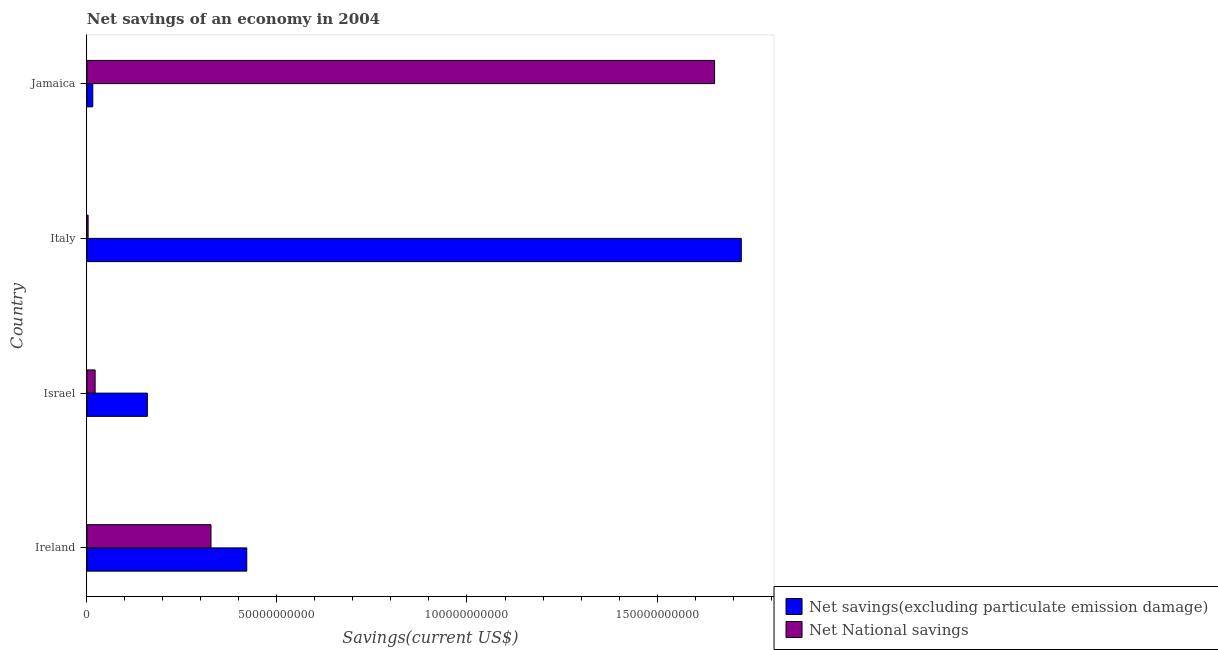How many different coloured bars are there?
Give a very brief answer. 2. Are the number of bars on each tick of the Y-axis equal?
Your answer should be very brief. Yes. What is the label of the 1st group of bars from the top?
Provide a succinct answer. Jamaica. In how many cases, is the number of bars for a given country not equal to the number of legend labels?
Keep it short and to the point. 0. What is the net national savings in Israel?
Make the answer very short. 2.16e+09. Across all countries, what is the maximum net national savings?
Your answer should be very brief. 1.65e+11. Across all countries, what is the minimum net savings(excluding particulate emission damage)?
Offer a very short reply. 1.55e+09. In which country was the net national savings minimum?
Your answer should be very brief. Italy. What is the total net national savings in the graph?
Give a very brief answer. 2.00e+11. What is the difference between the net savings(excluding particulate emission damage) in Ireland and that in Israel?
Ensure brevity in your answer.  2.62e+1. What is the difference between the net savings(excluding particulate emission damage) in Jamaica and the net national savings in Italy?
Provide a succinct answer. 1.23e+09. What is the average net savings(excluding particulate emission damage) per country?
Your response must be concise. 5.79e+1. What is the difference between the net national savings and net savings(excluding particulate emission damage) in Jamaica?
Offer a very short reply. 1.64e+11. What is the ratio of the net national savings in Italy to that in Jamaica?
Your response must be concise. 0. What is the difference between the highest and the second highest net savings(excluding particulate emission damage)?
Your answer should be very brief. 1.30e+11. What is the difference between the highest and the lowest net savings(excluding particulate emission damage)?
Provide a short and direct response. 1.71e+11. In how many countries, is the net national savings greater than the average net national savings taken over all countries?
Your answer should be very brief. 1. What does the 1st bar from the top in Ireland represents?
Give a very brief answer. Net National savings. What does the 2nd bar from the bottom in Jamaica represents?
Your answer should be compact. Net National savings. How many bars are there?
Offer a terse response. 8. Are all the bars in the graph horizontal?
Keep it short and to the point. Yes. How many countries are there in the graph?
Your answer should be very brief. 4. Does the graph contain grids?
Offer a very short reply. No. Where does the legend appear in the graph?
Give a very brief answer. Bottom right. What is the title of the graph?
Keep it short and to the point. Net savings of an economy in 2004. Does "UN agencies" appear as one of the legend labels in the graph?
Offer a very short reply. No. What is the label or title of the X-axis?
Offer a terse response. Savings(current US$). What is the label or title of the Y-axis?
Offer a terse response. Country. What is the Savings(current US$) of Net savings(excluding particulate emission damage) in Ireland?
Offer a terse response. 4.21e+1. What is the Savings(current US$) in Net National savings in Ireland?
Keep it short and to the point. 3.27e+1. What is the Savings(current US$) of Net savings(excluding particulate emission damage) in Israel?
Offer a very short reply. 1.59e+1. What is the Savings(current US$) in Net National savings in Israel?
Offer a terse response. 2.16e+09. What is the Savings(current US$) in Net savings(excluding particulate emission damage) in Italy?
Make the answer very short. 1.72e+11. What is the Savings(current US$) in Net National savings in Italy?
Offer a very short reply. 3.24e+08. What is the Savings(current US$) of Net savings(excluding particulate emission damage) in Jamaica?
Offer a very short reply. 1.55e+09. What is the Savings(current US$) in Net National savings in Jamaica?
Provide a succinct answer. 1.65e+11. Across all countries, what is the maximum Savings(current US$) in Net savings(excluding particulate emission damage)?
Offer a very short reply. 1.72e+11. Across all countries, what is the maximum Savings(current US$) of Net National savings?
Offer a terse response. 1.65e+11. Across all countries, what is the minimum Savings(current US$) of Net savings(excluding particulate emission damage)?
Provide a short and direct response. 1.55e+09. Across all countries, what is the minimum Savings(current US$) of Net National savings?
Keep it short and to the point. 3.24e+08. What is the total Savings(current US$) in Net savings(excluding particulate emission damage) in the graph?
Your response must be concise. 2.32e+11. What is the total Savings(current US$) in Net National savings in the graph?
Offer a very short reply. 2.00e+11. What is the difference between the Savings(current US$) in Net savings(excluding particulate emission damage) in Ireland and that in Israel?
Make the answer very short. 2.62e+1. What is the difference between the Savings(current US$) in Net National savings in Ireland and that in Israel?
Keep it short and to the point. 3.05e+1. What is the difference between the Savings(current US$) of Net savings(excluding particulate emission damage) in Ireland and that in Italy?
Your answer should be very brief. -1.30e+11. What is the difference between the Savings(current US$) in Net National savings in Ireland and that in Italy?
Your response must be concise. 3.23e+1. What is the difference between the Savings(current US$) in Net savings(excluding particulate emission damage) in Ireland and that in Jamaica?
Offer a terse response. 4.05e+1. What is the difference between the Savings(current US$) in Net National savings in Ireland and that in Jamaica?
Keep it short and to the point. -1.32e+11. What is the difference between the Savings(current US$) in Net savings(excluding particulate emission damage) in Israel and that in Italy?
Give a very brief answer. -1.56e+11. What is the difference between the Savings(current US$) of Net National savings in Israel and that in Italy?
Make the answer very short. 1.84e+09. What is the difference between the Savings(current US$) in Net savings(excluding particulate emission damage) in Israel and that in Jamaica?
Provide a short and direct response. 1.44e+1. What is the difference between the Savings(current US$) of Net National savings in Israel and that in Jamaica?
Provide a short and direct response. -1.63e+11. What is the difference between the Savings(current US$) of Net savings(excluding particulate emission damage) in Italy and that in Jamaica?
Your answer should be compact. 1.71e+11. What is the difference between the Savings(current US$) in Net National savings in Italy and that in Jamaica?
Keep it short and to the point. -1.65e+11. What is the difference between the Savings(current US$) in Net savings(excluding particulate emission damage) in Ireland and the Savings(current US$) in Net National savings in Israel?
Provide a succinct answer. 3.99e+1. What is the difference between the Savings(current US$) in Net savings(excluding particulate emission damage) in Ireland and the Savings(current US$) in Net National savings in Italy?
Your answer should be compact. 4.17e+1. What is the difference between the Savings(current US$) in Net savings(excluding particulate emission damage) in Ireland and the Savings(current US$) in Net National savings in Jamaica?
Your answer should be compact. -1.23e+11. What is the difference between the Savings(current US$) in Net savings(excluding particulate emission damage) in Israel and the Savings(current US$) in Net National savings in Italy?
Give a very brief answer. 1.56e+1. What is the difference between the Savings(current US$) in Net savings(excluding particulate emission damage) in Israel and the Savings(current US$) in Net National savings in Jamaica?
Your answer should be compact. -1.49e+11. What is the difference between the Savings(current US$) in Net savings(excluding particulate emission damage) in Italy and the Savings(current US$) in Net National savings in Jamaica?
Give a very brief answer. 7.03e+09. What is the average Savings(current US$) of Net savings(excluding particulate emission damage) per country?
Give a very brief answer. 5.79e+1. What is the average Savings(current US$) in Net National savings per country?
Your response must be concise. 5.01e+1. What is the difference between the Savings(current US$) of Net savings(excluding particulate emission damage) and Savings(current US$) of Net National savings in Ireland?
Keep it short and to the point. 9.41e+09. What is the difference between the Savings(current US$) of Net savings(excluding particulate emission damage) and Savings(current US$) of Net National savings in Israel?
Make the answer very short. 1.37e+1. What is the difference between the Savings(current US$) in Net savings(excluding particulate emission damage) and Savings(current US$) in Net National savings in Italy?
Offer a terse response. 1.72e+11. What is the difference between the Savings(current US$) of Net savings(excluding particulate emission damage) and Savings(current US$) of Net National savings in Jamaica?
Make the answer very short. -1.64e+11. What is the ratio of the Savings(current US$) in Net savings(excluding particulate emission damage) in Ireland to that in Israel?
Give a very brief answer. 2.64. What is the ratio of the Savings(current US$) in Net National savings in Ireland to that in Israel?
Provide a succinct answer. 15.09. What is the ratio of the Savings(current US$) in Net savings(excluding particulate emission damage) in Ireland to that in Italy?
Provide a short and direct response. 0.24. What is the ratio of the Savings(current US$) in Net National savings in Ireland to that in Italy?
Offer a terse response. 100.77. What is the ratio of the Savings(current US$) in Net savings(excluding particulate emission damage) in Ireland to that in Jamaica?
Offer a terse response. 27.12. What is the ratio of the Savings(current US$) of Net National savings in Ireland to that in Jamaica?
Provide a short and direct response. 0.2. What is the ratio of the Savings(current US$) in Net savings(excluding particulate emission damage) in Israel to that in Italy?
Your response must be concise. 0.09. What is the ratio of the Savings(current US$) of Net National savings in Israel to that in Italy?
Offer a very short reply. 6.68. What is the ratio of the Savings(current US$) in Net savings(excluding particulate emission damage) in Israel to that in Jamaica?
Make the answer very short. 10.26. What is the ratio of the Savings(current US$) of Net National savings in Israel to that in Jamaica?
Provide a succinct answer. 0.01. What is the ratio of the Savings(current US$) of Net savings(excluding particulate emission damage) in Italy to that in Jamaica?
Your answer should be very brief. 111.02. What is the ratio of the Savings(current US$) in Net National savings in Italy to that in Jamaica?
Provide a succinct answer. 0. What is the difference between the highest and the second highest Savings(current US$) in Net savings(excluding particulate emission damage)?
Make the answer very short. 1.30e+11. What is the difference between the highest and the second highest Savings(current US$) of Net National savings?
Keep it short and to the point. 1.32e+11. What is the difference between the highest and the lowest Savings(current US$) in Net savings(excluding particulate emission damage)?
Offer a very short reply. 1.71e+11. What is the difference between the highest and the lowest Savings(current US$) of Net National savings?
Offer a very short reply. 1.65e+11. 